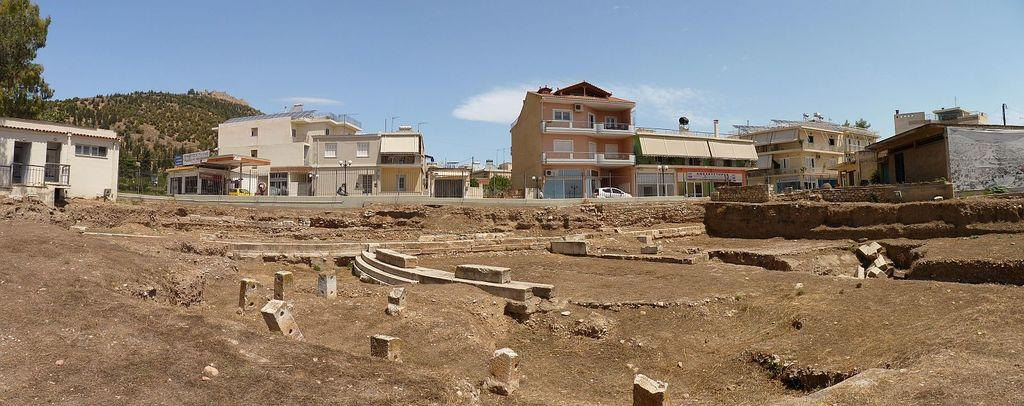What is the primary surface visible in the image? There is a ground in the image. What structures are located in front of the ground? There are buildings and houses constructed in front of the ground. What can be seen in the background of the image? There is a mountain visible in the background. What type of vegetation is on the left side of the image? There is a tree on the left side of the image. What type of fruit is hanging from the tree on the left side of the image? There is no fruit visible on the tree in the image. Is there an island present in the image? There is no island present in the image. 